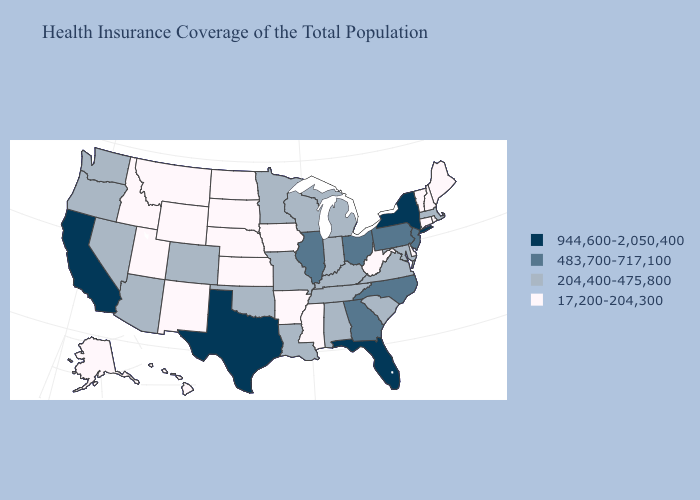Does Illinois have a lower value than Hawaii?
Write a very short answer. No. What is the lowest value in the Northeast?
Write a very short answer. 17,200-204,300. Name the states that have a value in the range 483,700-717,100?
Write a very short answer. Georgia, Illinois, New Jersey, North Carolina, Ohio, Pennsylvania. Does Iowa have the lowest value in the MidWest?
Give a very brief answer. Yes. Name the states that have a value in the range 204,400-475,800?
Be succinct. Alabama, Arizona, Colorado, Indiana, Kentucky, Louisiana, Maryland, Massachusetts, Michigan, Minnesota, Missouri, Nevada, Oklahoma, Oregon, South Carolina, Tennessee, Virginia, Washington, Wisconsin. What is the highest value in the USA?
Concise answer only. 944,600-2,050,400. Which states have the highest value in the USA?
Concise answer only. California, Florida, New York, Texas. Name the states that have a value in the range 17,200-204,300?
Give a very brief answer. Alaska, Arkansas, Connecticut, Delaware, Hawaii, Idaho, Iowa, Kansas, Maine, Mississippi, Montana, Nebraska, New Hampshire, New Mexico, North Dakota, Rhode Island, South Dakota, Utah, Vermont, West Virginia, Wyoming. Does the first symbol in the legend represent the smallest category?
Answer briefly. No. What is the highest value in states that border Delaware?
Short answer required. 483,700-717,100. Does Massachusetts have the lowest value in the Northeast?
Keep it brief. No. Which states have the highest value in the USA?
Give a very brief answer. California, Florida, New York, Texas. What is the lowest value in the USA?
Answer briefly. 17,200-204,300. Name the states that have a value in the range 944,600-2,050,400?
Keep it brief. California, Florida, New York, Texas. Does Utah have the lowest value in the West?
Write a very short answer. Yes. 